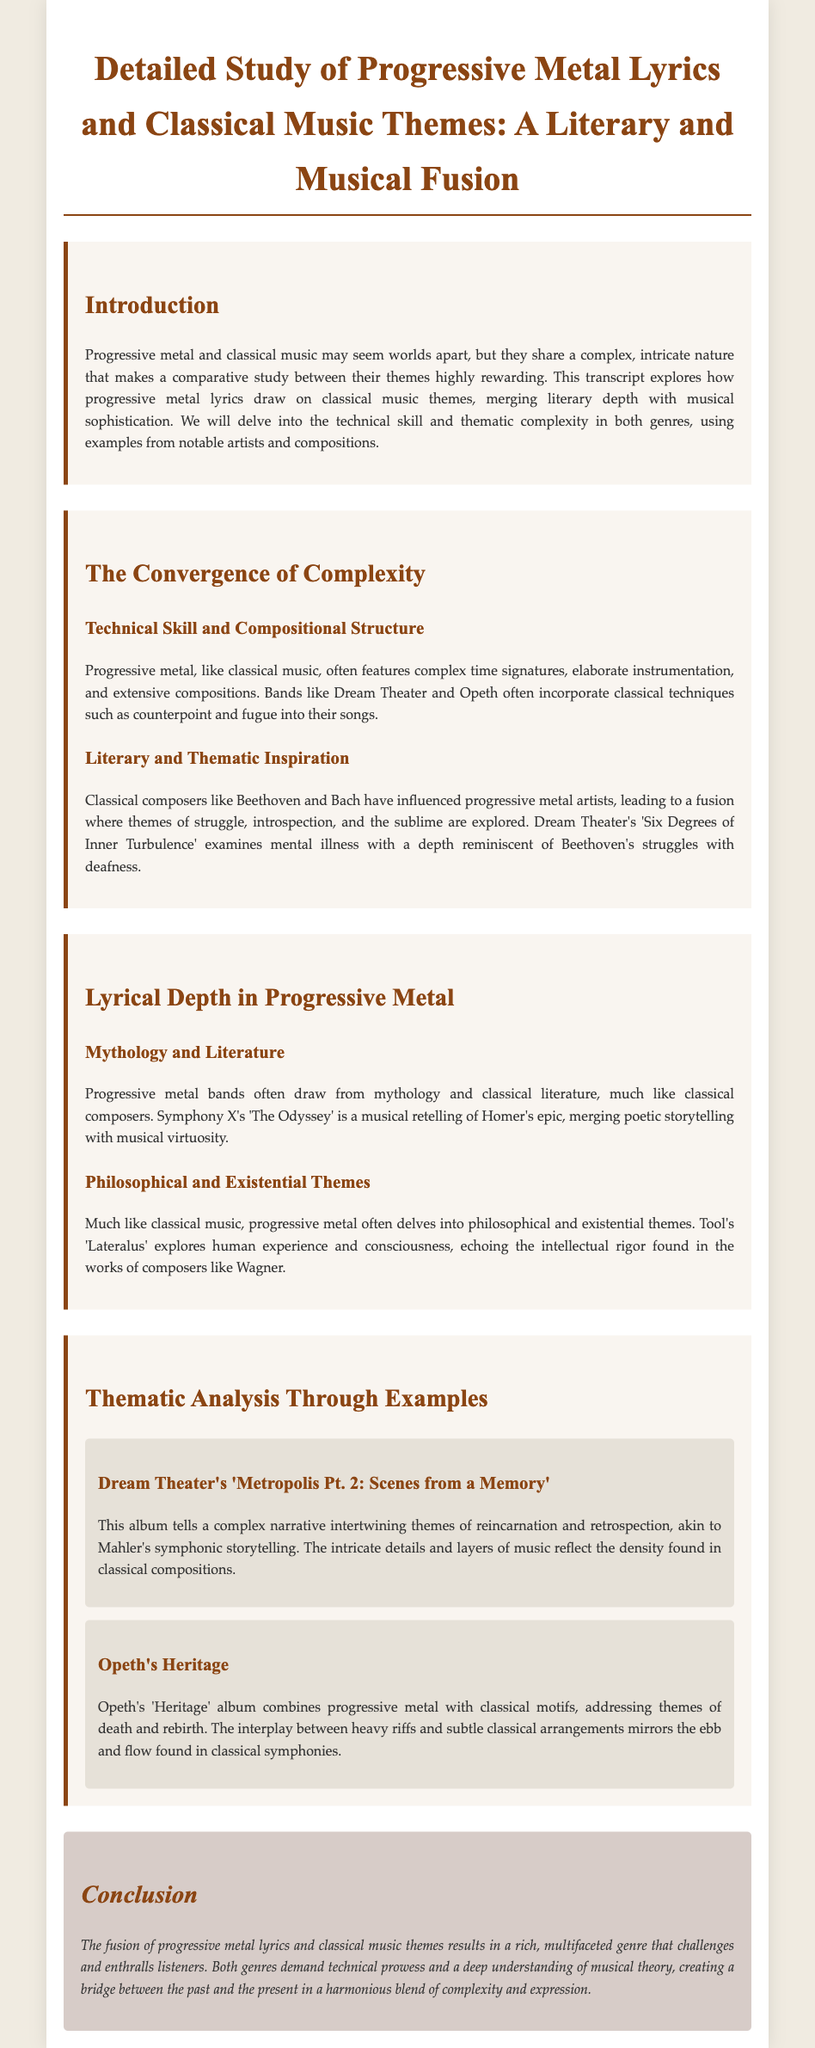What is the main focus of the study? The study focuses on the comparison of themes in progressive metal lyrics and classical music, highlighting their literary and musical fusion.
Answer: Comparative study of themes Which bands are mentioned as examples of progressive metal? The bands Dream Theater and Opeth are highlighted for their incorporation of classical techniques in their music.
Answer: Dream Theater and Opeth What is the title of Symphony X's musical retelling? Symphony X's work referred to in the document is 'The Odyssey', which draws from Homer's epic.
Answer: The Odyssey Which philosophical work is mentioned in relation to Tool's 'Lateralus'? Tool's 'Lateralus' is connected to the intellectual rigor of Wagner’s works.
Answer: Wagner What common thematic element is explored in Opeth's 'Heritage'? Opeth's 'Heritage' explores themes of death and rebirth within the context of progressive metal and classical motifs.
Answer: Death and rebirth How does the document describe the relationship between progressive metal and classical music? The document describes the relationship as a fusion producing a rich, multifaceted genre that blends complexity and expression.
Answer: Harmonious blend of complexity and expression Which album tells a narrative of reincarnation? Dream Theater's 'Metropolis Pt. 2: Scenes from a Memory' tells this complex narrative.
Answer: Metropolis Pt. 2: Scenes from a Memory What literary tradition do progressive metal bands often draw from? Progressive metal bands often draw from mythology and classical literature, similar to classical composers.
Answer: Mythology and classical literature 